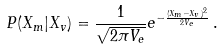Convert formula to latex. <formula><loc_0><loc_0><loc_500><loc_500>P ( X _ { m } | X _ { v } ) = \frac { 1 } { \sqrt { 2 \pi V _ { e } } } e ^ { - \frac { ( X _ { m } - X _ { v } ) ^ { 2 } } { 2 V _ { e } } } \, .</formula> 